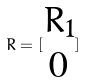<formula> <loc_0><loc_0><loc_500><loc_500>R = [ \begin{matrix} R _ { 1 } \\ 0 \end{matrix} ]</formula> 